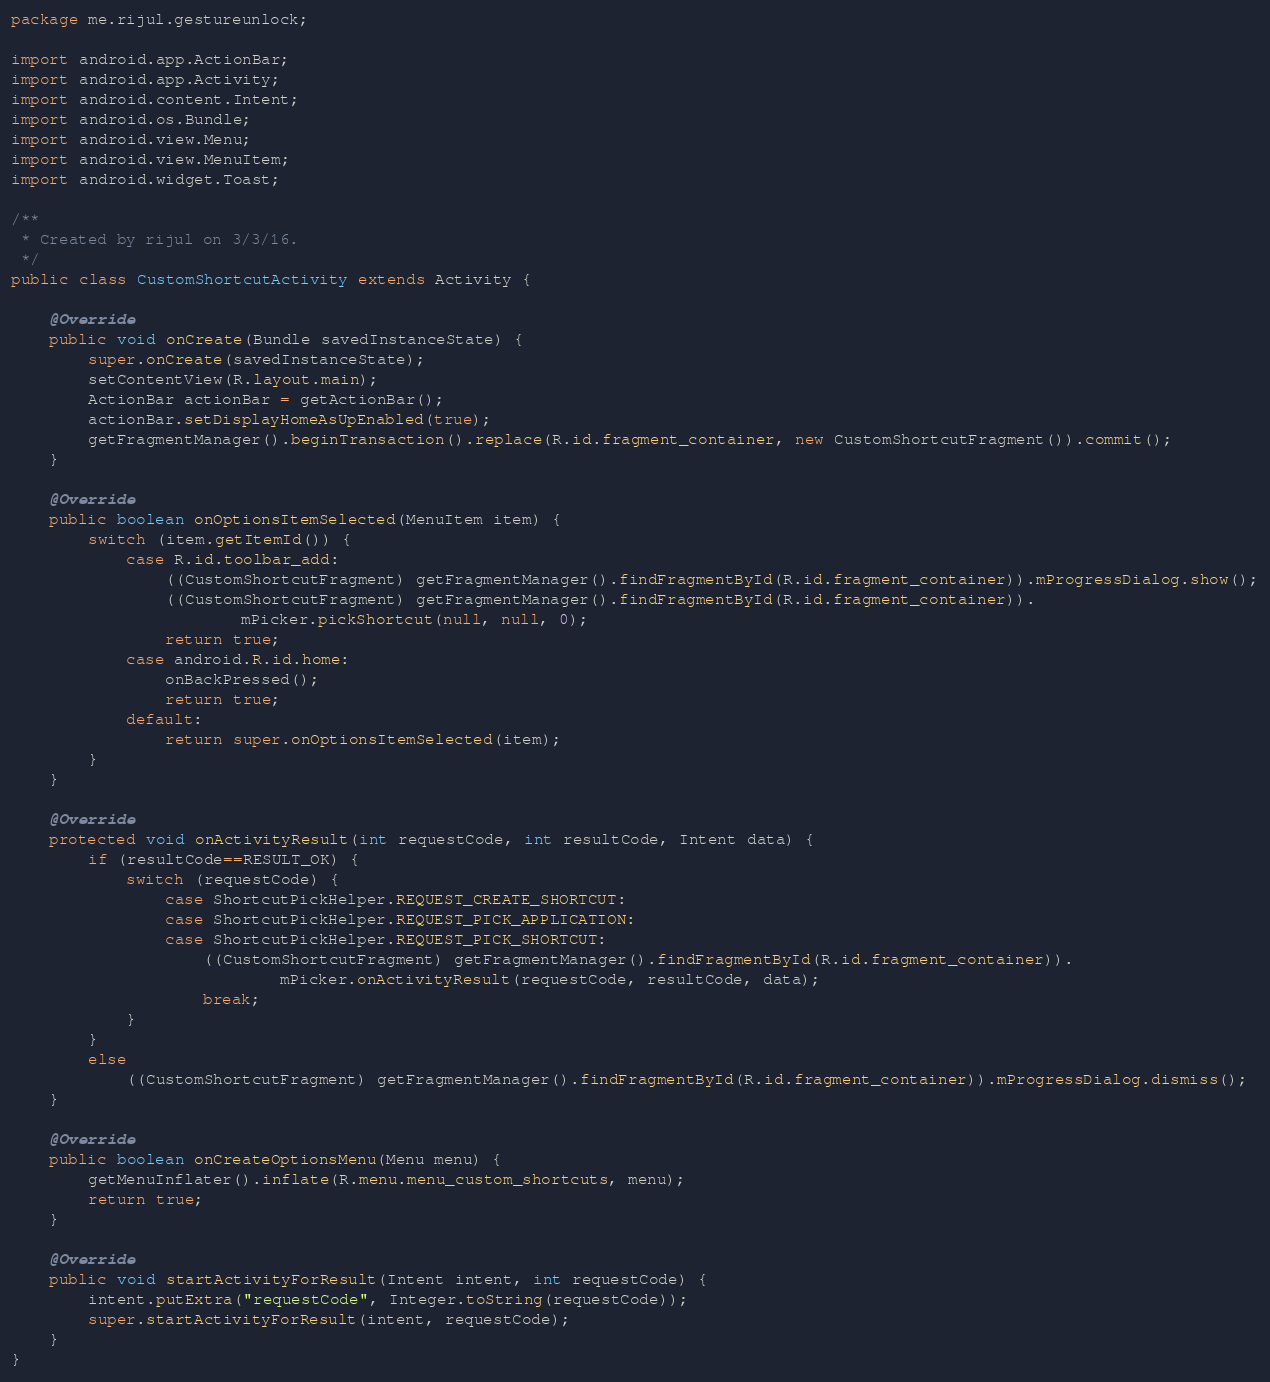Convert code to text. <code><loc_0><loc_0><loc_500><loc_500><_Java_>package me.rijul.gestureunlock;

import android.app.ActionBar;
import android.app.Activity;
import android.content.Intent;
import android.os.Bundle;
import android.view.Menu;
import android.view.MenuItem;
import android.widget.Toast;

/**
 * Created by rijul on 3/3/16.
 */
public class CustomShortcutActivity extends Activity {

    @Override
    public void onCreate(Bundle savedInstanceState) {
        super.onCreate(savedInstanceState);
        setContentView(R.layout.main);
        ActionBar actionBar = getActionBar();
        actionBar.setDisplayHomeAsUpEnabled(true);
        getFragmentManager().beginTransaction().replace(R.id.fragment_container, new CustomShortcutFragment()).commit();
    }

    @Override
    public boolean onOptionsItemSelected(MenuItem item) {
        switch (item.getItemId()) {
            case R.id.toolbar_add:
                ((CustomShortcutFragment) getFragmentManager().findFragmentById(R.id.fragment_container)).mProgressDialog.show();
                ((CustomShortcutFragment) getFragmentManager().findFragmentById(R.id.fragment_container)).
                        mPicker.pickShortcut(null, null, 0);
                return true;
            case android.R.id.home:
                onBackPressed();
                return true;
            default:
                return super.onOptionsItemSelected(item);
        }
    }

    @Override
    protected void onActivityResult(int requestCode, int resultCode, Intent data) {
        if (resultCode==RESULT_OK) {
            switch (requestCode) {
                case ShortcutPickHelper.REQUEST_CREATE_SHORTCUT:
                case ShortcutPickHelper.REQUEST_PICK_APPLICATION:
                case ShortcutPickHelper.REQUEST_PICK_SHORTCUT:
                    ((CustomShortcutFragment) getFragmentManager().findFragmentById(R.id.fragment_container)).
                            mPicker.onActivityResult(requestCode, resultCode, data);
                    break;
            }
        }
        else
            ((CustomShortcutFragment) getFragmentManager().findFragmentById(R.id.fragment_container)).mProgressDialog.dismiss();
    }

    @Override
    public boolean onCreateOptionsMenu(Menu menu) {
        getMenuInflater().inflate(R.menu.menu_custom_shortcuts, menu);
        return true;
    }

    @Override
    public void startActivityForResult(Intent intent, int requestCode) {
        intent.putExtra("requestCode", Integer.toString(requestCode));
        super.startActivityForResult(intent, requestCode);
    }
}
</code> 